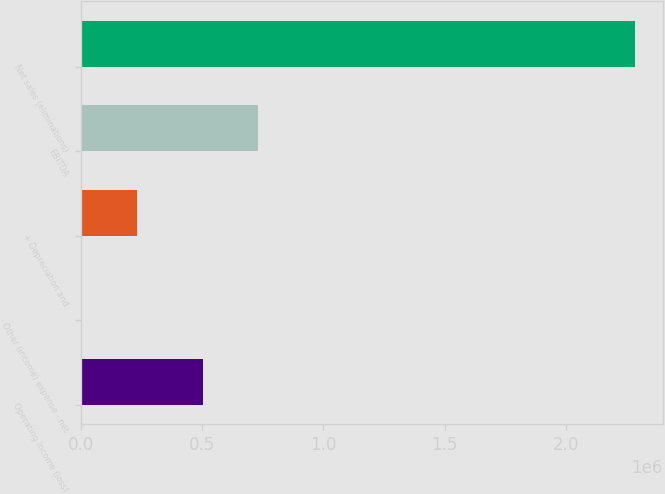<chart> <loc_0><loc_0><loc_500><loc_500><bar_chart><fcel>Operating income (loss)<fcel>- Other (income) expense - net<fcel>+ Depreciation and<fcel>EBITDA<fcel>Net sales (eliminations)<nl><fcel>502556<fcel>2394<fcel>230886<fcel>731048<fcel>2.28731e+06<nl></chart> 